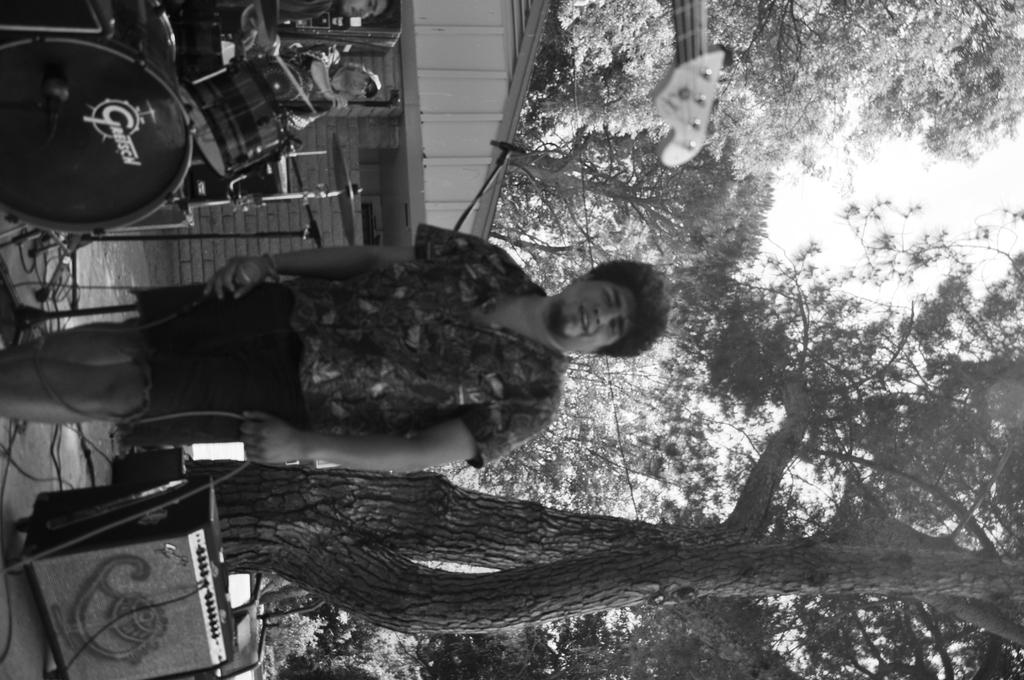What is the main subject of the image? There is a man standing in the image. Can you describe what the man is wearing? The man is wearing clothes. What is the man holding in his hand? The man is holding a cable wire in his hand. What else can be seen in the image besides the man? There are musical instruments, a building, trees, and the sky visible in the image. How many chickens are visible in the image? There are no chickens present in the image. What type of form does the fog take in the image? There is no fog present in the image. 